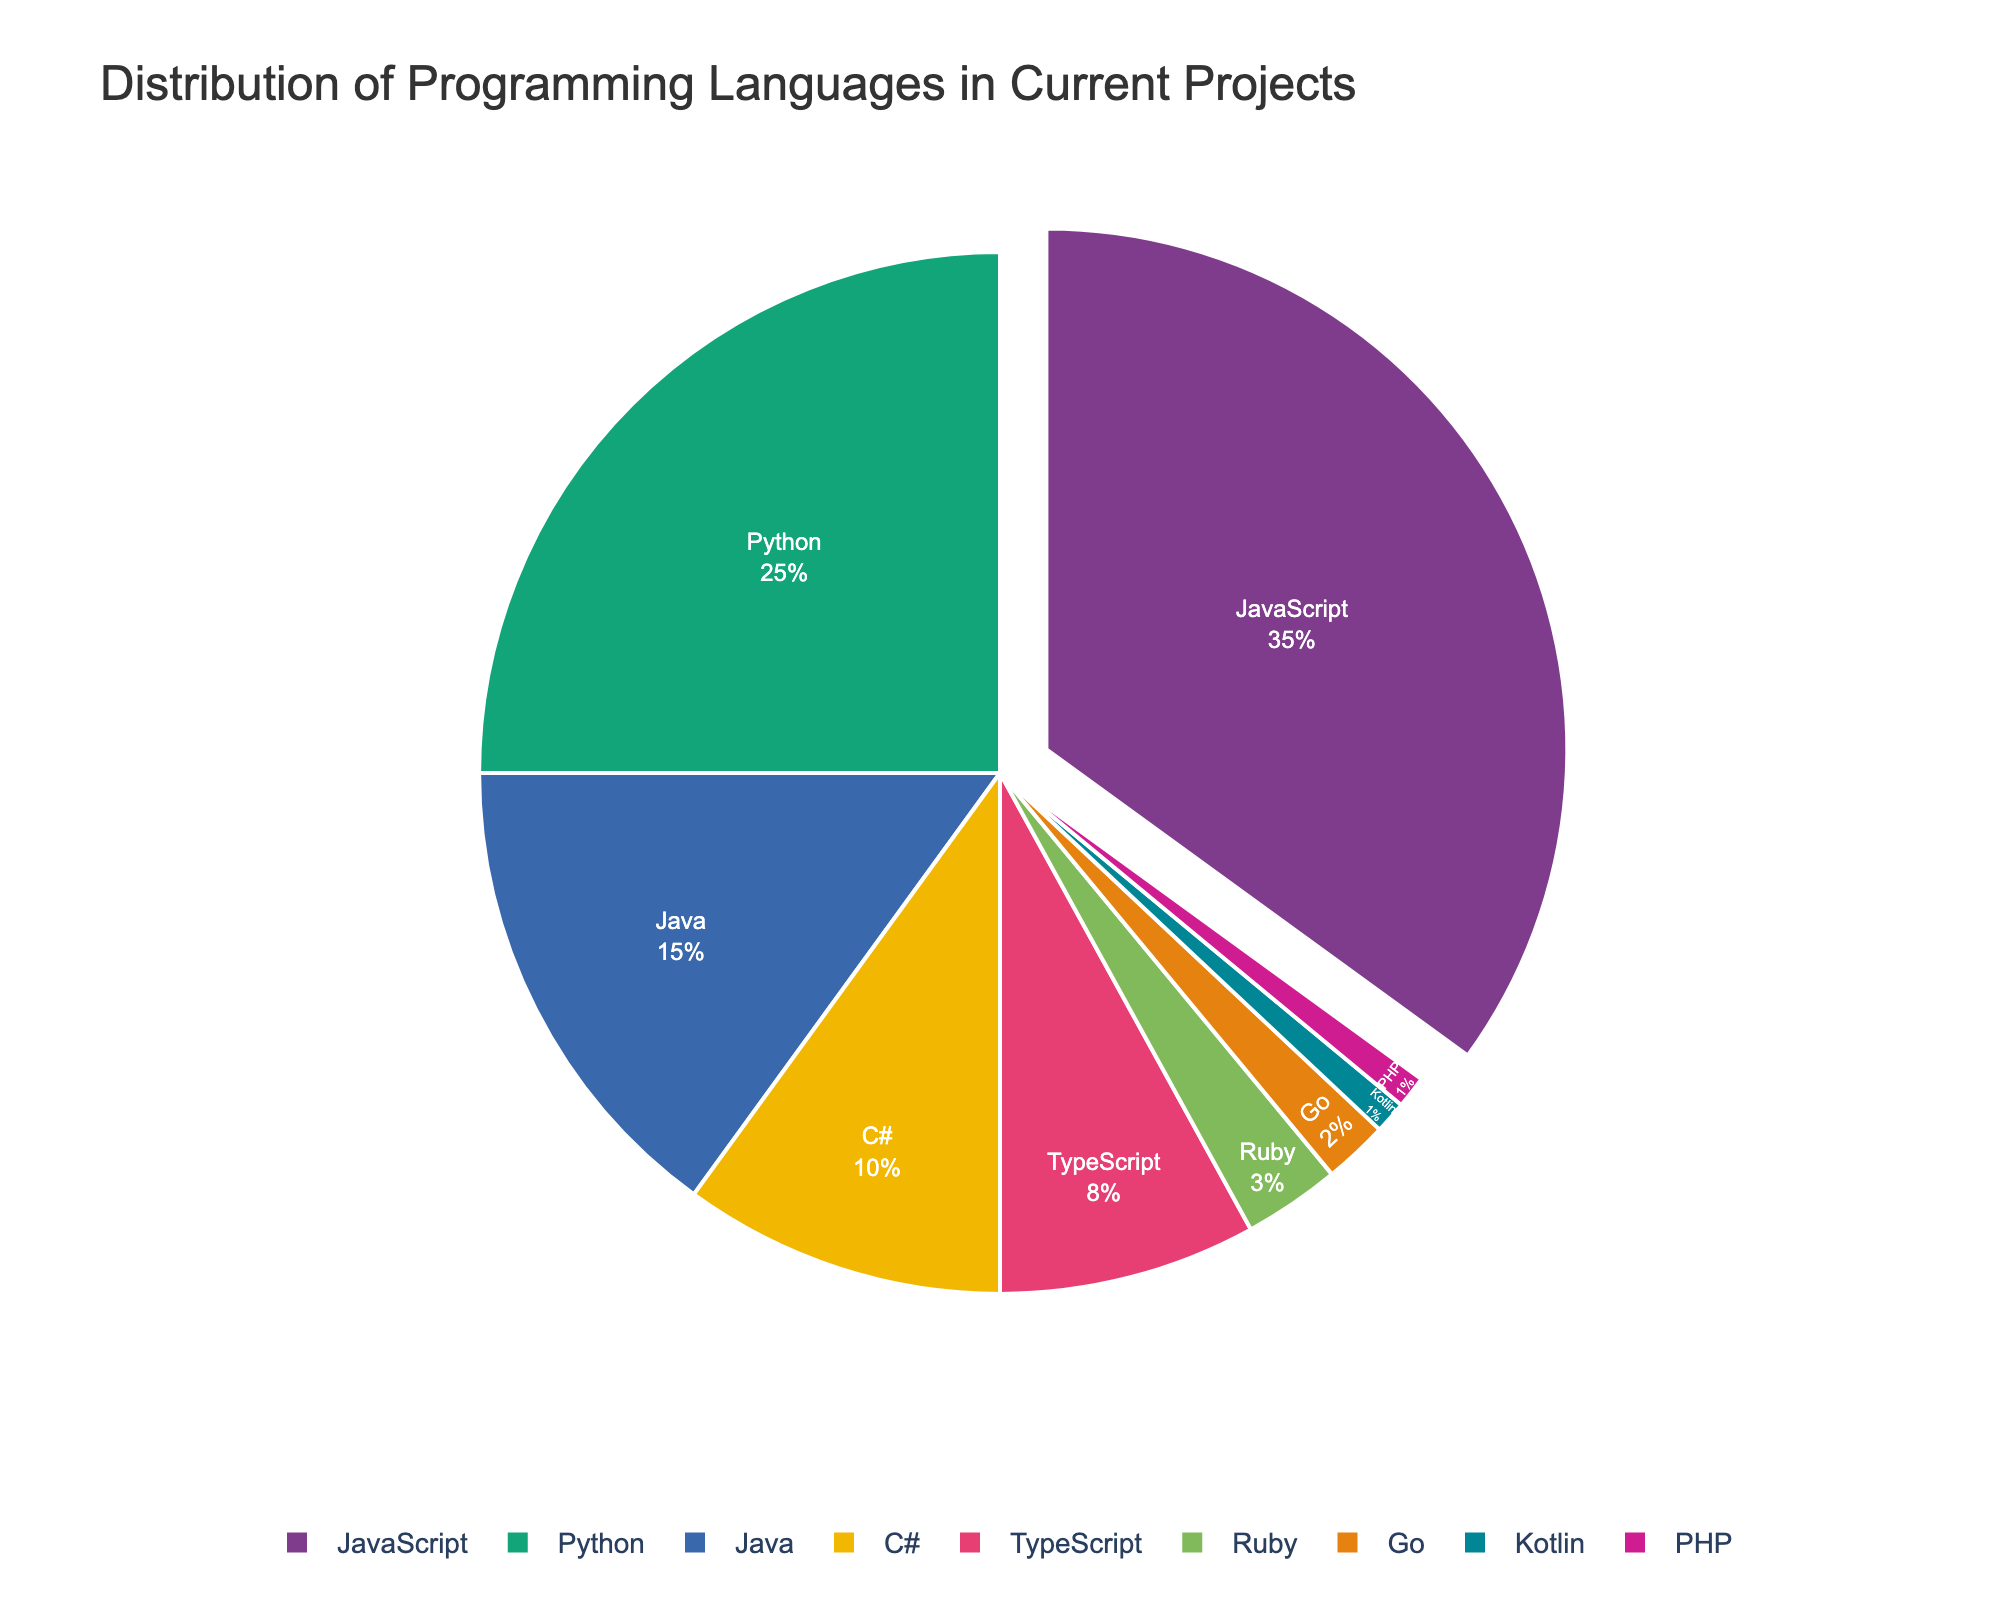Which programming language is used most frequently in current projects? By observing the pie chart, the largest slice corresponds to JavaScript with a percentage of 35%. The legend confirms this information.
Answer: JavaScript How much more frequently is Python used compared to Ruby? According to the chart, Python occupies 25% of the distribution, whereas Ruby holds 3%. The difference is computed as 25% - 3% = 22%.
Answer: 22% If you combined TypeScript, Ruby, Go, Kotlin, and PHP, what percentage of the overall usage would that be? The slices for TypeScript, Ruby, Go, Kotlin, and PHP represent 8%, 3%, 2%, 1%, and 1%, respectively. Summing these percentages gives 8% + 3% + 2% + 1% + 1% = 15%.
Answer: 15% Is Java used more frequently than C#? The slices of the pie chart indicate that Java holds 15%, while C# holds 10%. Since 15% is greater than 10%, Java is used more frequently than C#.
Answer: Yes What are the three least-used programming languages in current projects? By examining the smallest slices of the pie chart, we see that Kotlin, PHP, and Go have the smallest percentages of 1%, 1%, and 2%, respectively.
Answer: Kotlin, PHP, Go Which programming languages together make up more than half (50%) of the total usage? Summing the percentages for JavaScript (35%) and Python (25%) gives 60%. Since 60% is greater than 50%, JavaScript and Python together make up more than half of the total usage.
Answer: JavaScript, Python Among JavaScript, Python, and Java, which language has the smallest proportion of usage? The chart shows JavaScript has 35%, Python has 25%, and Java has 15%. Among these, Java has the smallest proportion of usage.
Answer: Java How much larger is the usage of JavaScript compared to C#? From the pie chart, JavaScript accounts for 35% and C# accounts for 10%. The difference is calculated as 35% - 10% = 25%.
Answer: 25% What is the total percentage of projects that use either Python or Java? Python usage is 25% and Java usage is 15%. Summing these percentages gives 25% + 15% = 40%.
Answer: 40% What color represents TypeScript in the pie chart, and where is it positioned relative to Go? The pie chart uses distinct colors for each language, with TypeScript colored green. TypeScript is positioned to the right of Go, which is colored pastel purple.
Answer: Green, right of Go 